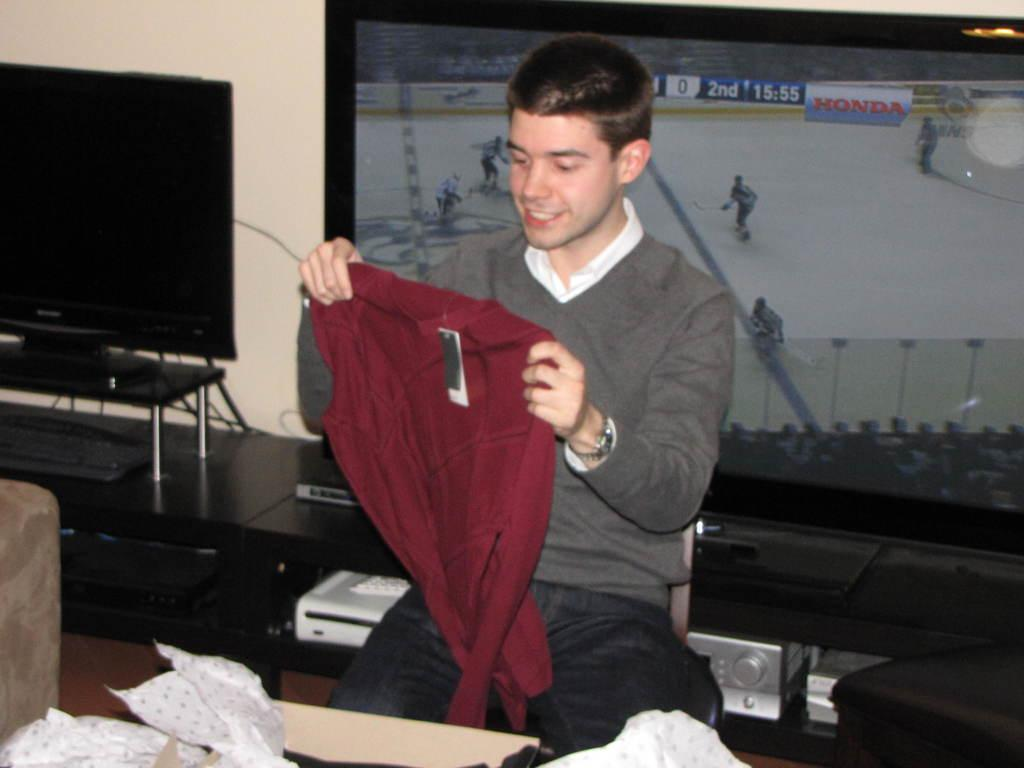Provide a one-sentence caption for the provided image. A man holding up a new sweater with a tv in the background showing the 2nd period of a hockey game. 